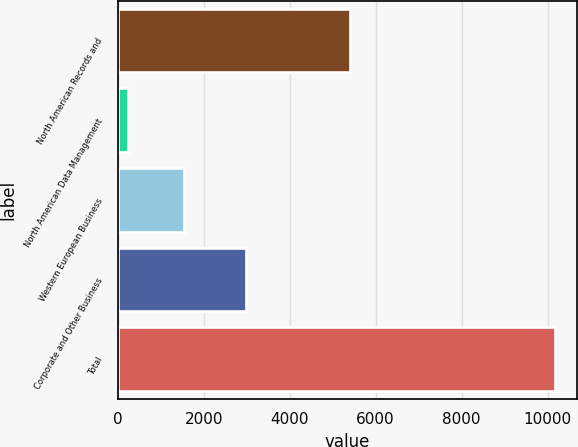Convert chart to OTSL. <chart><loc_0><loc_0><loc_500><loc_500><bar_chart><fcel>North American Records and<fcel>North American Data Management<fcel>Western European Business<fcel>Corporate and Other Business<fcel>Total<nl><fcel>5403<fcel>241<fcel>1537<fcel>2986<fcel>10167<nl></chart> 